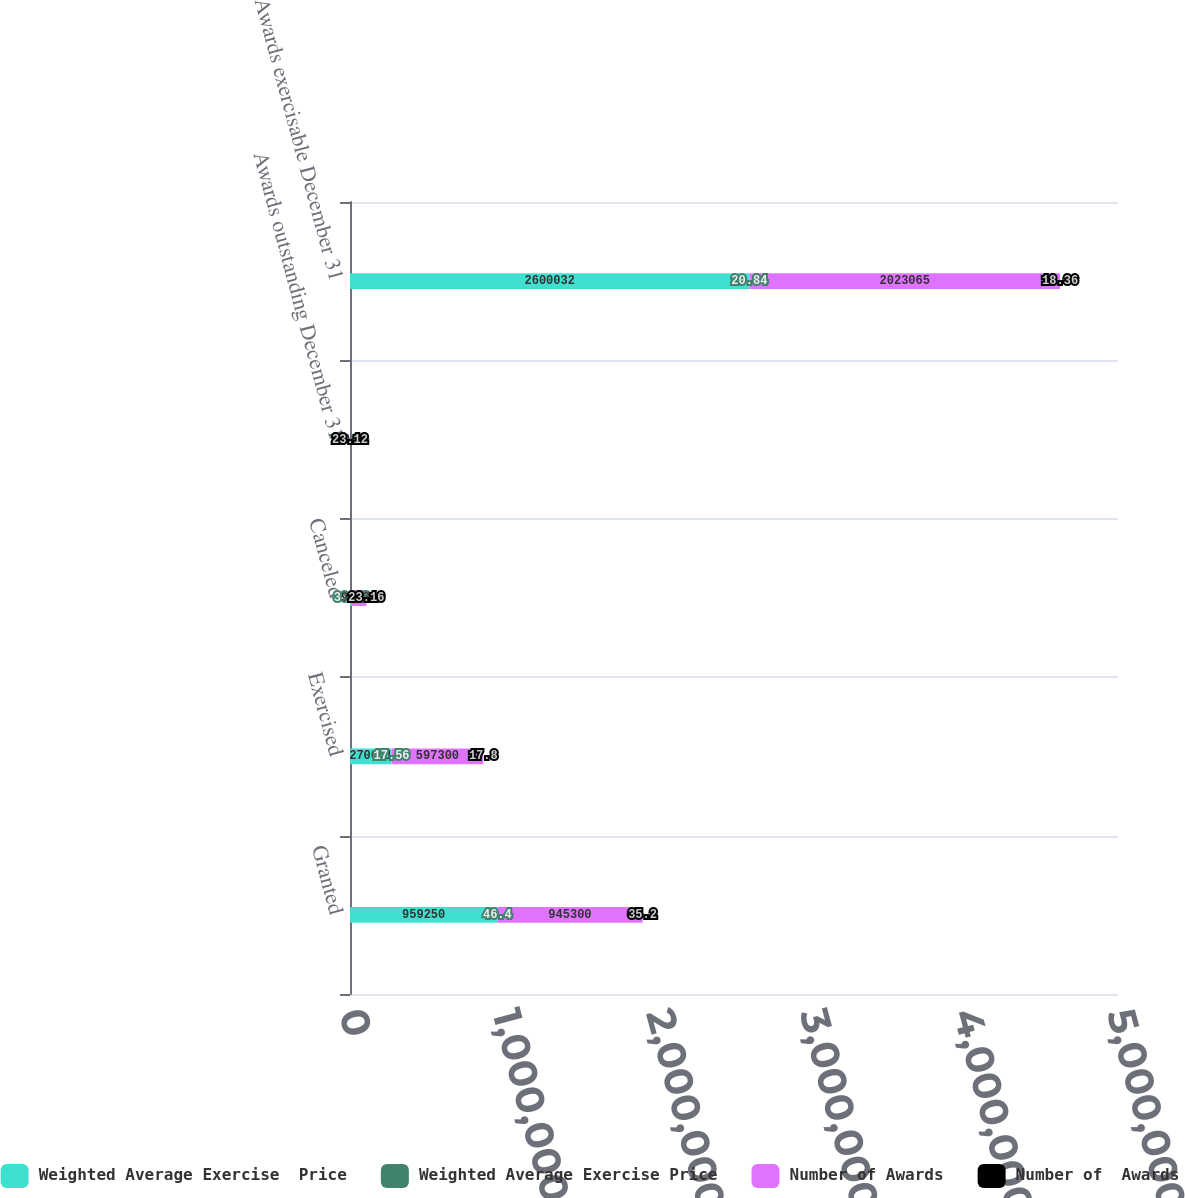<chart> <loc_0><loc_0><loc_500><loc_500><stacked_bar_chart><ecel><fcel>Granted<fcel>Exercised<fcel>Canceled<fcel>Awards outstanding December 31<fcel>Awards exercisable December 31<nl><fcel>Weighted Average Exercise  Price<fcel>959250<fcel>270641<fcel>12010<fcel>40.8<fcel>2.60003e+06<nl><fcel>Weighted Average Exercise Price<fcel>46.4<fcel>17.56<fcel>30.13<fcel>28.09<fcel>20.84<nl><fcel>Number of Awards<fcel>945300<fcel>597300<fcel>94532<fcel>40.8<fcel>2.02306e+06<nl><fcel>Number of  Awards<fcel>35.2<fcel>17.8<fcel>23.16<fcel>23.12<fcel>18.36<nl></chart> 